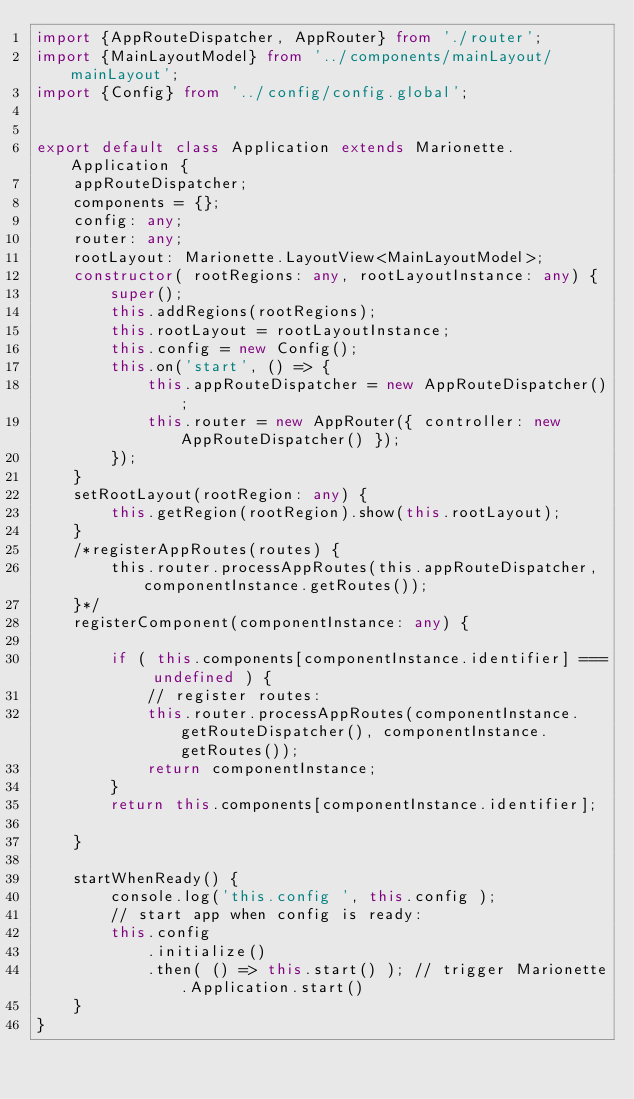<code> <loc_0><loc_0><loc_500><loc_500><_TypeScript_>import {AppRouteDispatcher, AppRouter} from './router';
import {MainLayoutModel} from '../components/mainLayout/mainLayout';
import {Config} from '../config/config.global';


export default class Application extends Marionette.Application {
    appRouteDispatcher;
    components = {};
    config: any;
    router: any;
    rootLayout: Marionette.LayoutView<MainLayoutModel>;
    constructor( rootRegions: any, rootLayoutInstance: any) {
        super();
        this.addRegions(rootRegions);
        this.rootLayout = rootLayoutInstance;
        this.config = new Config();
        this.on('start', () => {
            this.appRouteDispatcher = new AppRouteDispatcher();
            this.router = new AppRouter({ controller: new AppRouteDispatcher() });
        });
    }
    setRootLayout(rootRegion: any) {
        this.getRegion(rootRegion).show(this.rootLayout);
    }
    /*registerAppRoutes(routes) {
        this.router.processAppRoutes(this.appRouteDispatcher, componentInstance.getRoutes());
    }*/
    registerComponent(componentInstance: any) {

        if ( this.components[componentInstance.identifier] === undefined ) {
            // register routes:
            this.router.processAppRoutes(componentInstance.getRouteDispatcher(), componentInstance.getRoutes());
            return componentInstance;
        }
        return this.components[componentInstance.identifier];

    }

    startWhenReady() {
        console.log('this.config ', this.config );
        // start app when config is ready:
        this.config
            .initialize()
            .then( () => this.start() ); // trigger Marionette.Application.start()
    }
}
</code> 